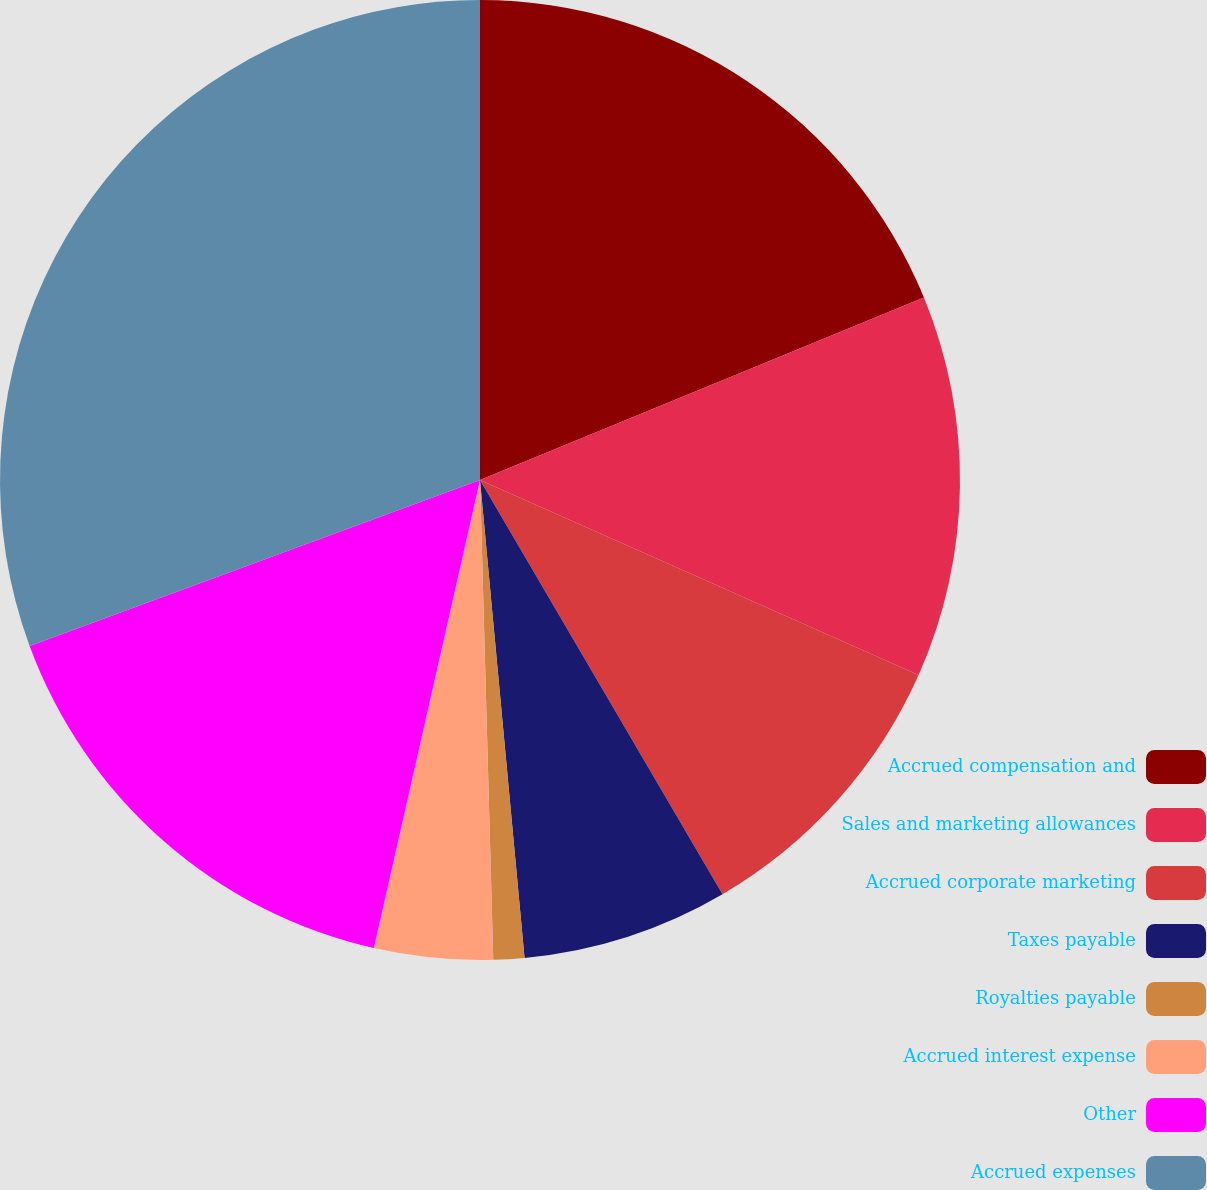Convert chart to OTSL. <chart><loc_0><loc_0><loc_500><loc_500><pie_chart><fcel>Accrued compensation and<fcel>Sales and marketing allowances<fcel>Accrued corporate marketing<fcel>Taxes payable<fcel>Royalties payable<fcel>Accrued interest expense<fcel>Other<fcel>Accrued expenses<nl><fcel>18.79%<fcel>12.87%<fcel>9.91%<fcel>6.95%<fcel>1.04%<fcel>3.99%<fcel>15.83%<fcel>30.62%<nl></chart> 